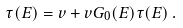<formula> <loc_0><loc_0><loc_500><loc_500>\tau ( E ) = v + v G _ { 0 } ( E ) \tau ( E ) \, .</formula> 